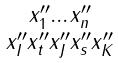Convert formula to latex. <formula><loc_0><loc_0><loc_500><loc_500>\begin{smallmatrix} x _ { 1 } ^ { \prime \prime } \dots x _ { n } ^ { \prime \prime } \\ x _ { I } ^ { \prime \prime } x _ { t } ^ { \prime \prime } x _ { J } ^ { \prime \prime } x _ { s } ^ { \prime \prime } x _ { K } ^ { \prime \prime } \end{smallmatrix}</formula> 